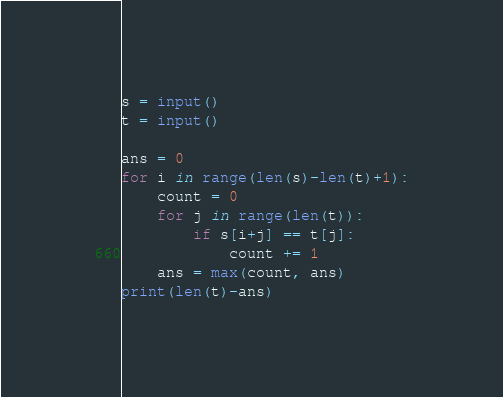Convert code to text. <code><loc_0><loc_0><loc_500><loc_500><_Python_>s = input()
t = input()

ans = 0
for i in range(len(s)-len(t)+1):
    count = 0
    for j in range(len(t)):
        if s[i+j] == t[j]:
            count += 1
    ans = max(count, ans)
print(len(t)-ans)
</code> 